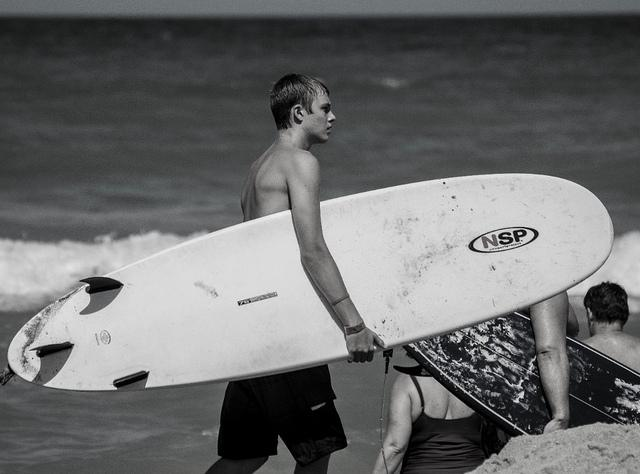What are the black triangular pieces on the board called? fins 